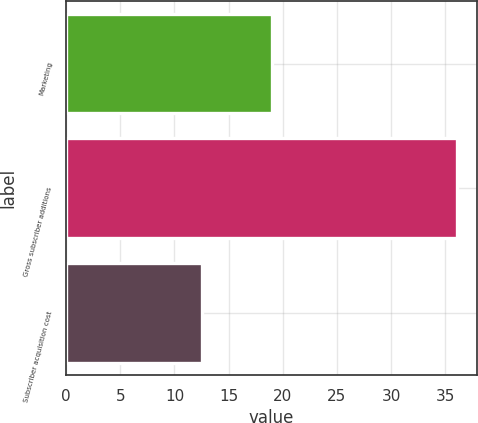<chart> <loc_0><loc_0><loc_500><loc_500><bar_chart><fcel>Marketing<fcel>Gross subscriber additions<fcel>Subscriber acquisition cost<nl><fcel>19<fcel>36.1<fcel>12.5<nl></chart> 